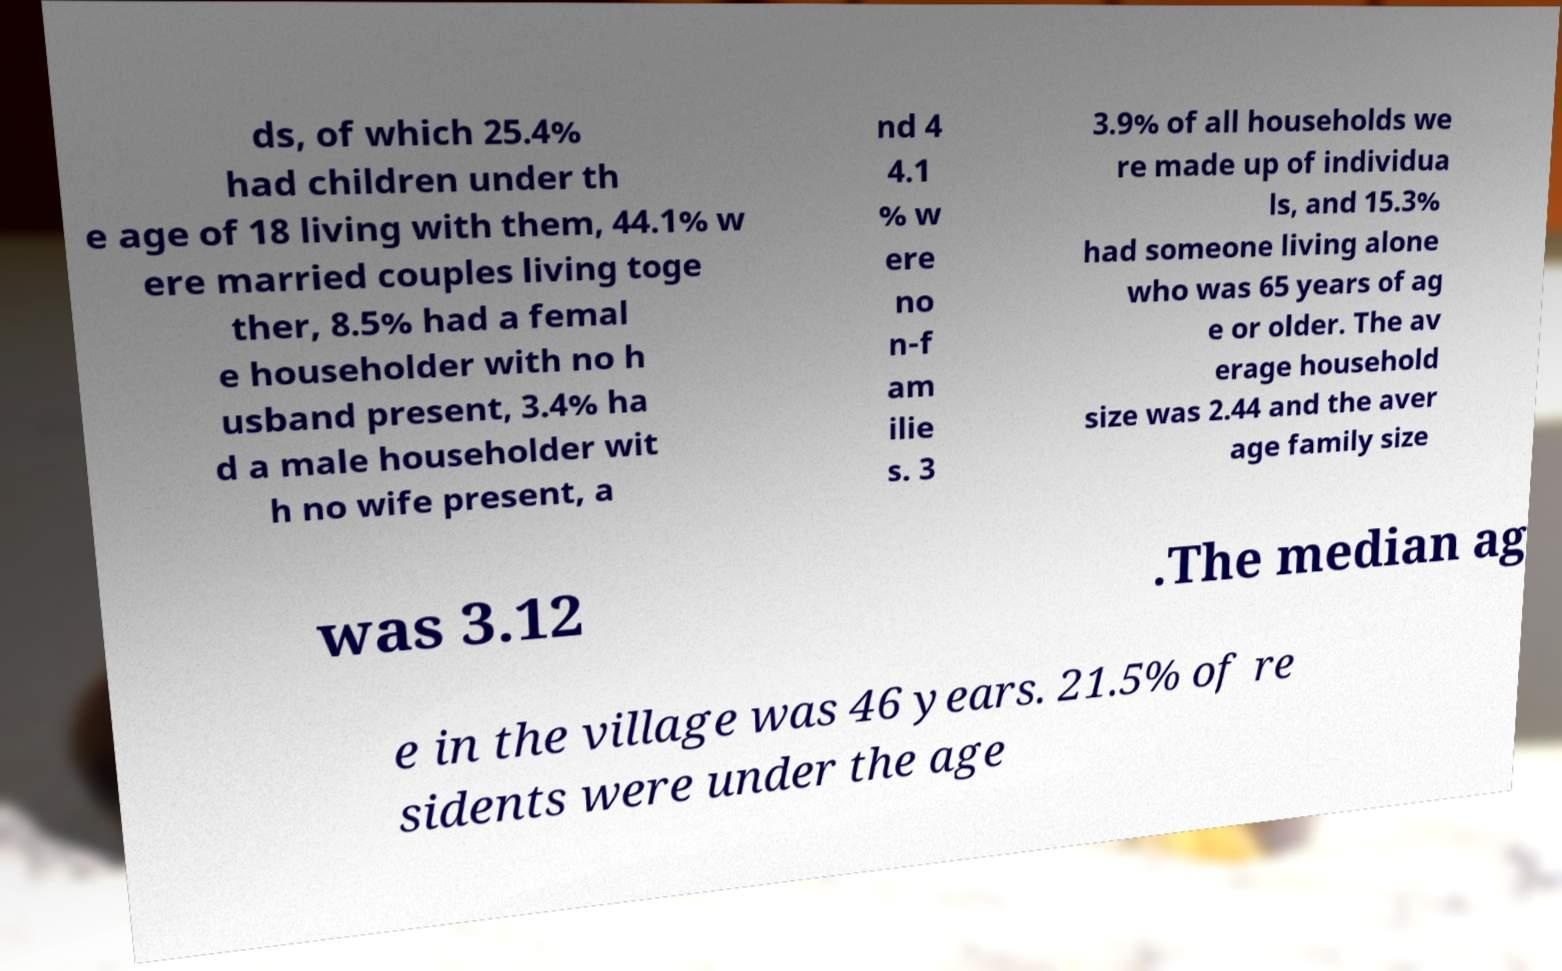There's text embedded in this image that I need extracted. Can you transcribe it verbatim? ds, of which 25.4% had children under th e age of 18 living with them, 44.1% w ere married couples living toge ther, 8.5% had a femal e householder with no h usband present, 3.4% ha d a male householder wit h no wife present, a nd 4 4.1 % w ere no n-f am ilie s. 3 3.9% of all households we re made up of individua ls, and 15.3% had someone living alone who was 65 years of ag e or older. The av erage household size was 2.44 and the aver age family size was 3.12 .The median ag e in the village was 46 years. 21.5% of re sidents were under the age 